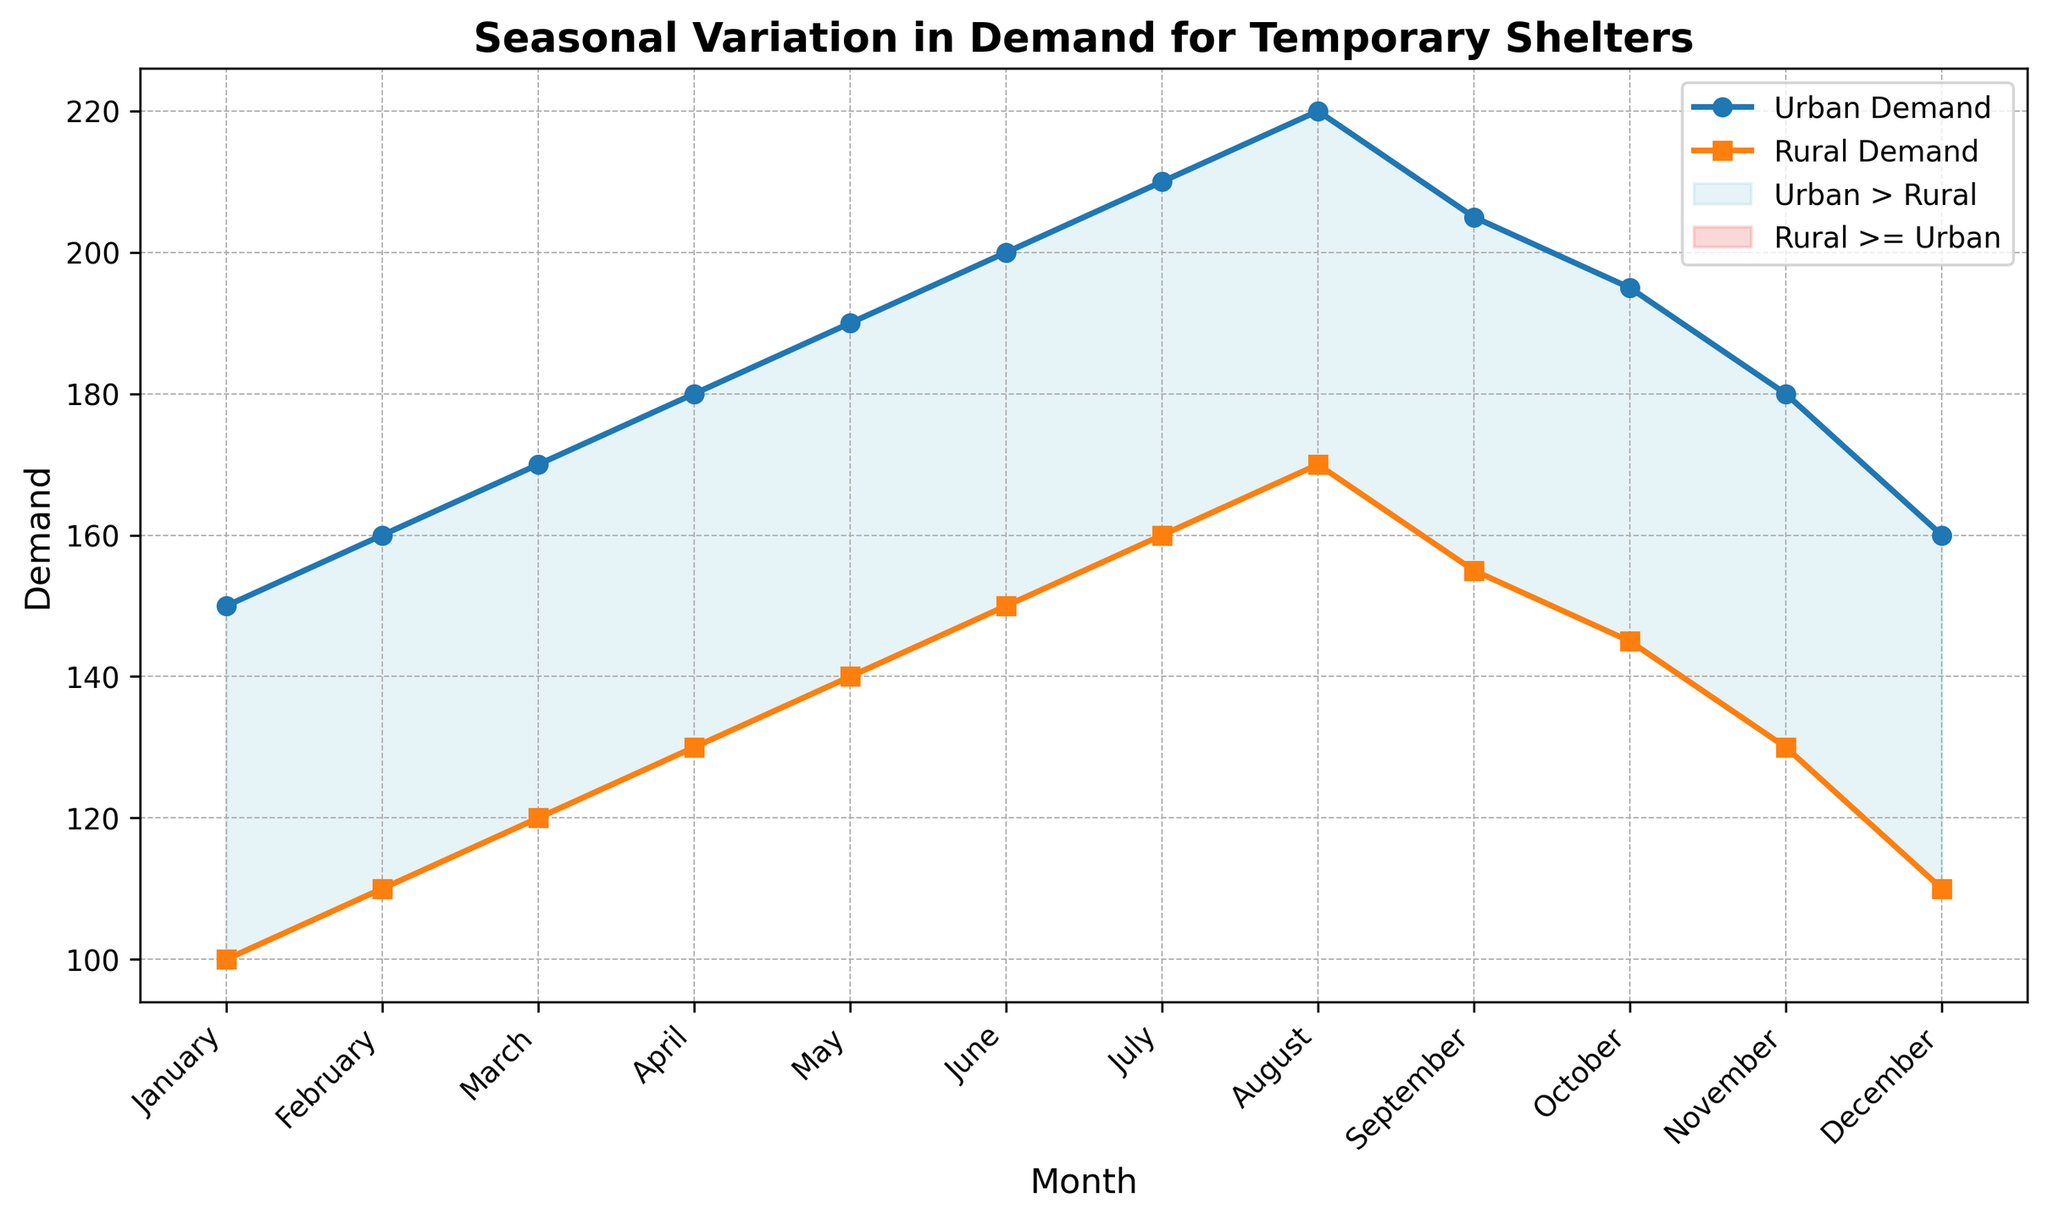Which month has the highest demand for urban temporary shelters? Inspect the visual line for the Urban Demand and find the peak point. The highest point in the Urban Demand line occurs in August.
Answer: August Which month has the lowest demand for rural temporary shelters? Look at the line for Rural Demand and find the lowest point on the graph. The lowest Rural Demand occurs in January.
Answer: January During which months is the urban demand higher than the rural demand? Observe the filled areas under the Urban Demand line that are shaded light blue, indicating Urban > Rural. This occurs in all months.
Answer: January to December What is the difference in demand between urban and rural shelters in July? Locate the data points for July on both lines, then subtract the Rural Demand from the Urban Demand. The Urban Demand in July is 210 and Rural Demand is 160, so the difference is 50.
Answer: 50 What is the average demand for rural shelters over the year? Sum the Rural Demand for all months and divide by the number of months (12). The total Rural Demand is 100 + 110 + 120 + 130 + 140 + 150 + 160 + 170 + 155 + 145 + 130 + 110 = 1720. The average is 1720 / 12 ≈ 143.3.
Answer: 143.3 Which two consecutive months show the most significant increase in urban demand? Examine the Urban Demand line for the steepest upward trend between two consecutive months. The largest increase occurs from July (210) to August (220), which is an increase of 10.
Answer: July to August In which months does the rural demand equal the urban demand? Examine the points where the Urban and Rural lines cross the months. They do not cross at any point in the graph, indicating they are never equal.
Answer: None What is the demand for urban shelters in November? Find the specific point for Urban Demand in the month of November. The graph indicates the Urban Demand in November is 180.
Answer: 180 